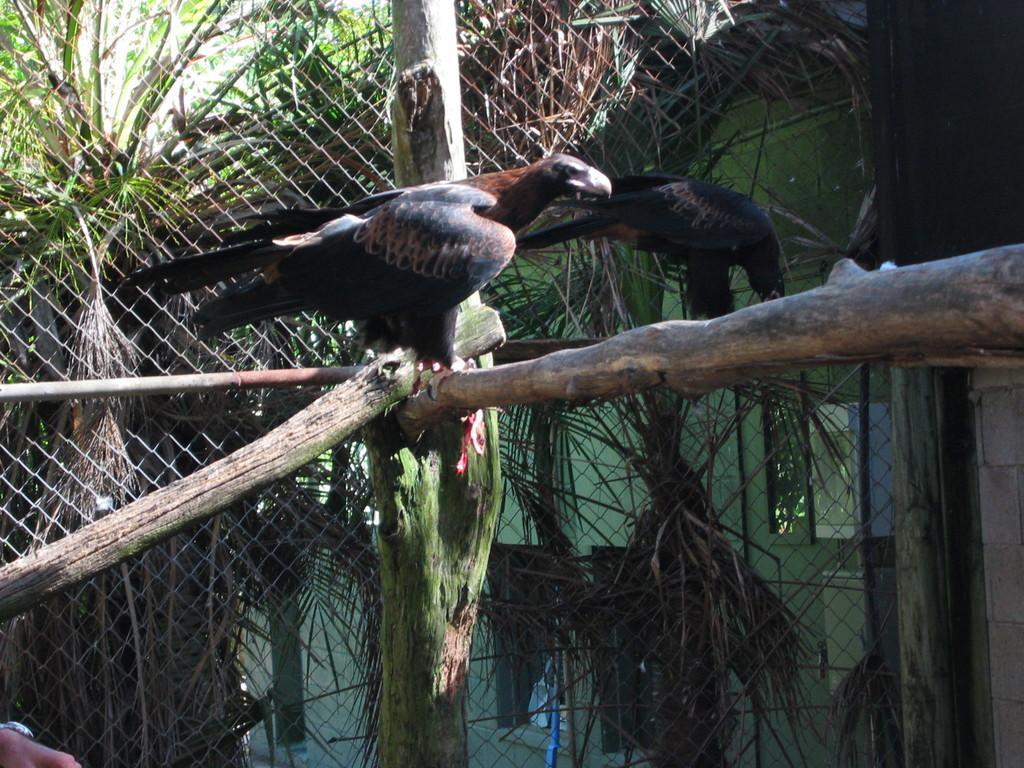How would you summarize this image in a sentence or two? In this image I can see few wooden poles and on it I can see two black colour birds. In the background I can see the fencing, a building and number of trees. On the bottom left corner of the image I can see a hand of a person. 